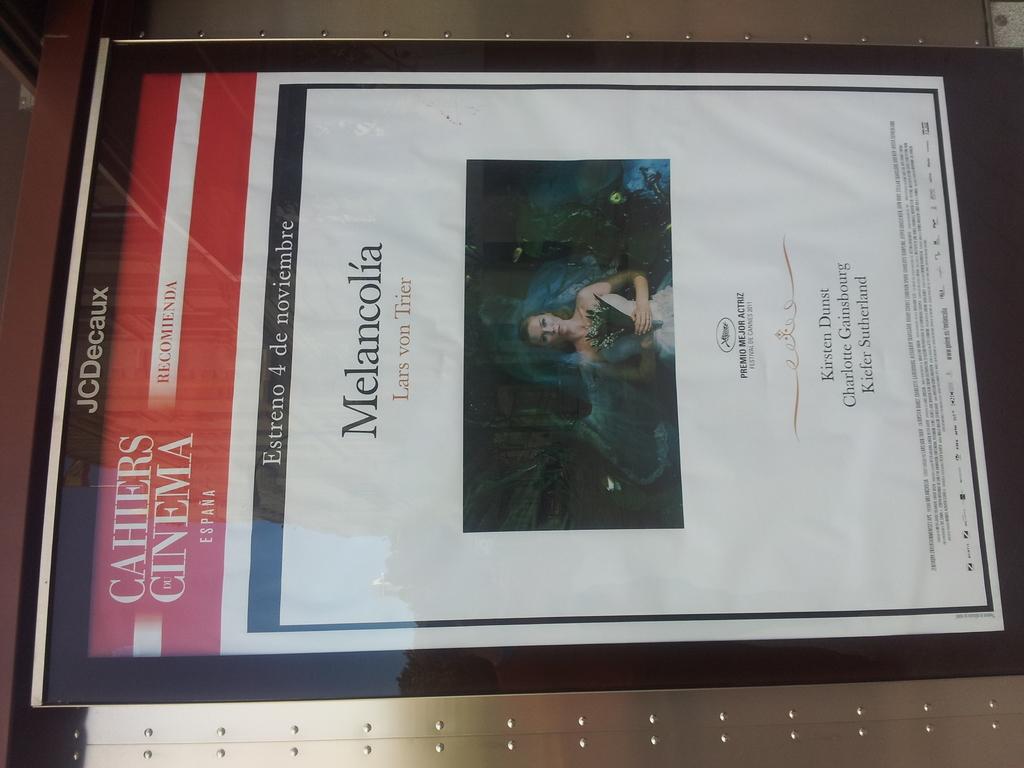What cinema was this picture taken in?
Offer a terse response. Cahiers cinema. What is the drama name advertised here?
Keep it short and to the point. Melancolia. 